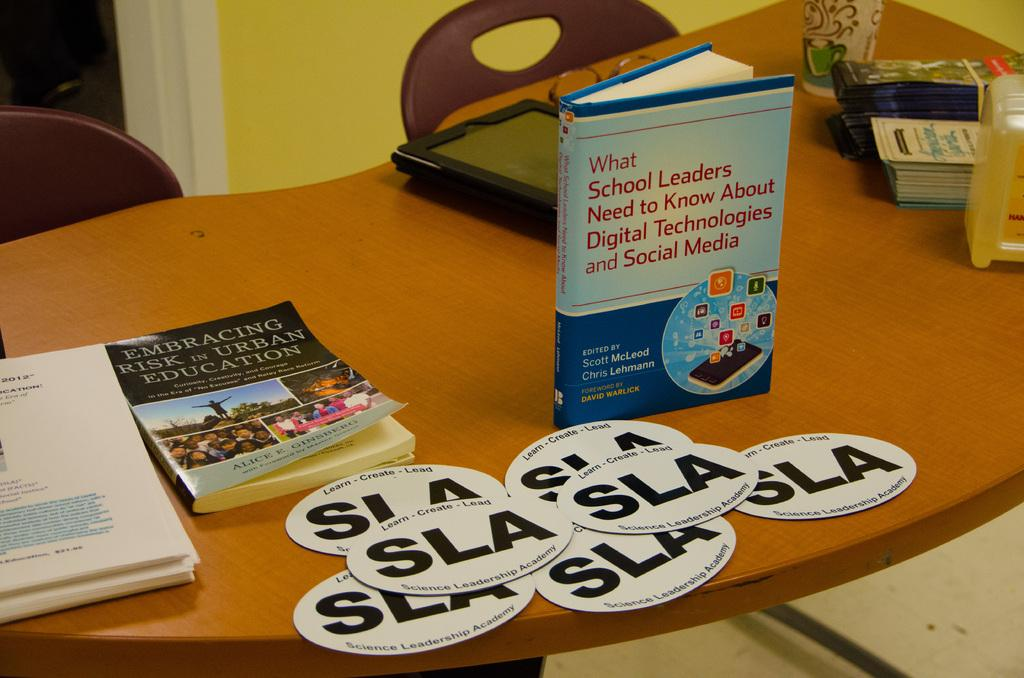<image>
Present a compact description of the photo's key features. Several books are on a table including Embracing Risk in Urban Education. 